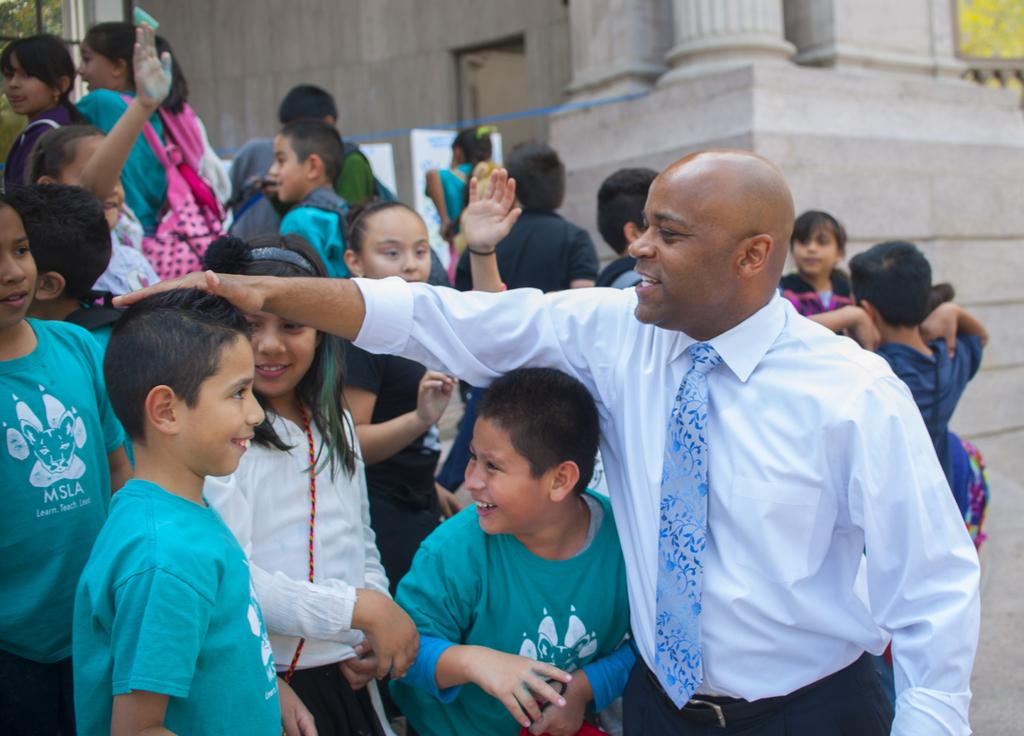What is happening in the image? There are people standing in the image. Can you describe the clothing of one of the individuals? A person on the right is wearing a white shirt and a tie. What can be seen in the distance behind the people? There is a building visible in the background of the image. What type of dinner is being served in the image? There is no dinner present in the image; it only shows people standing and a building in the background. 